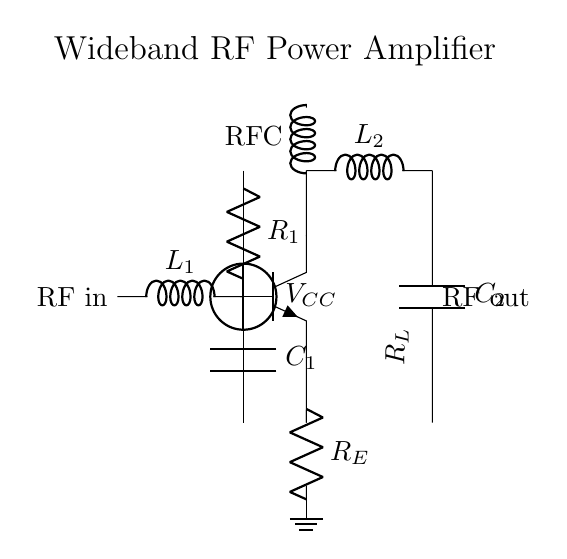What type of transistor is used in the circuit? The circuit shows an npn transistor, which is indicated by the symbol with the three terminals labeled B, C, and E corresponding to the base, collector, and emitter, respectively.
Answer: npn What is the value of the load resistor? The load resistor is represented by R_L in the output section of the circuit. It is labeled and is not tied to a specific value in the diagram, but typically it is a crucial component for the output.
Answer: R_L Which components form the input matching network? The input matching network consists of an inductor labeled L_1 and a capacitor labeled C_1, which are connected in series to match the input impedance of the amplifier to the source.
Answer: L_1, C_1 What is the purpose of the RF choke in this circuit? The RF choke is used to block high-frequency signals while allowing DC bias to flow through, thereby stabilizing the circuit and preventing unwanted oscillations due to RF signals.
Answer: Block RF signals How does the biasing work in this amplifier circuit? The biasing is provided through resistor R_1 connected to V_CC, which sets the operating point of the transistor. It ensures that the transistor is in the correct region of operation for amplification.
Answer: R_1 What does the output matching network comprise of? The output matching network includes an inductor labeled L_2 and a capacitor labeled C_2 connected between the collector and ground. This setup helps to match the amplifier's output impedance to the load for optimal power transfer.
Answer: L_2, C_2 